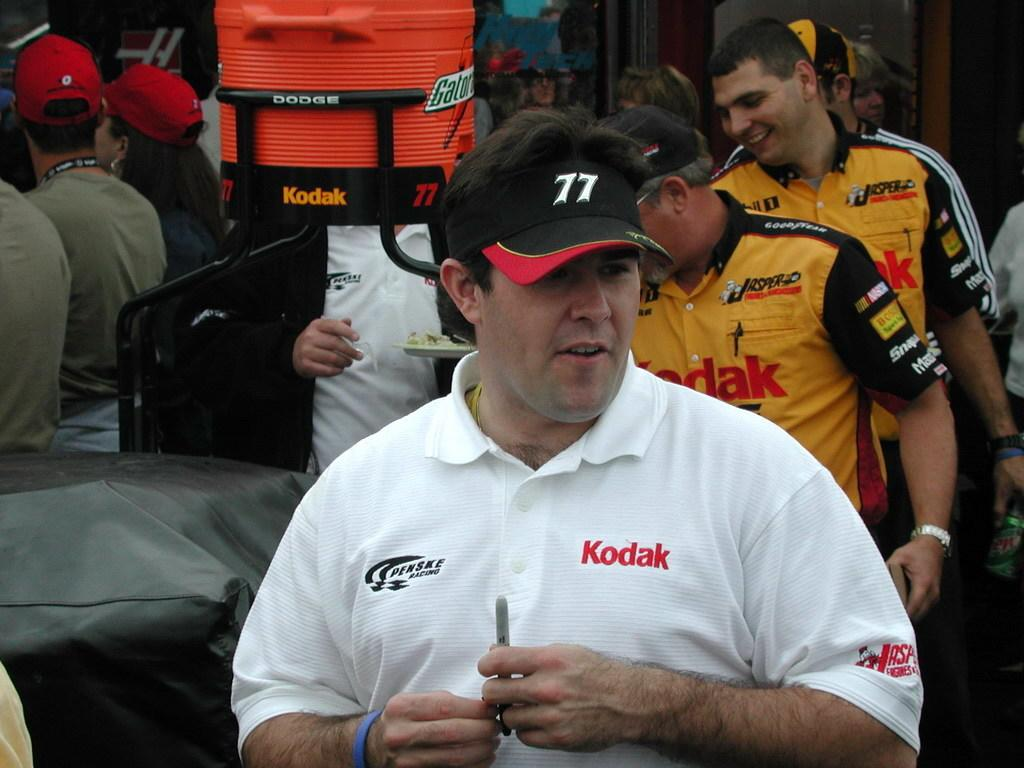<image>
Render a clear and concise summary of the photo. Men are standing near a gatorade cooler and smiling 